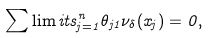<formula> <loc_0><loc_0><loc_500><loc_500>\sum \lim i t s _ { j = 1 } ^ { n } \theta _ { j 1 } \nu _ { \delta } ( x _ { j } ) = 0 ,</formula> 